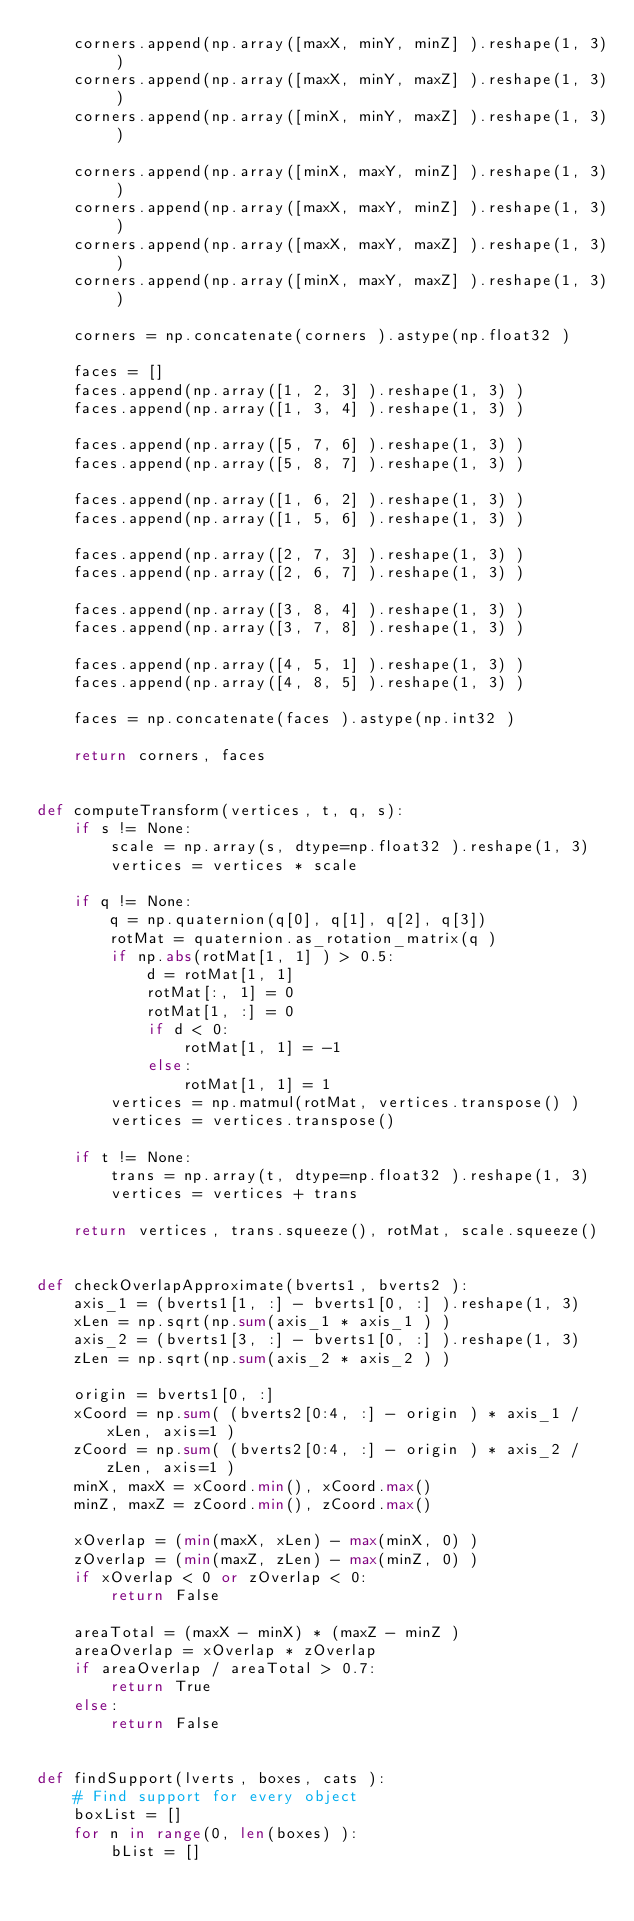Convert code to text. <code><loc_0><loc_0><loc_500><loc_500><_Python_>    corners.append(np.array([maxX, minY, minZ] ).reshape(1, 3) )
    corners.append(np.array([maxX, minY, maxZ] ).reshape(1, 3) )
    corners.append(np.array([minX, minY, maxZ] ).reshape(1, 3) )

    corners.append(np.array([minX, maxY, minZ] ).reshape(1, 3) )
    corners.append(np.array([maxX, maxY, minZ] ).reshape(1, 3) )
    corners.append(np.array([maxX, maxY, maxZ] ).reshape(1, 3) )
    corners.append(np.array([minX, maxY, maxZ] ).reshape(1, 3) )

    corners = np.concatenate(corners ).astype(np.float32 )

    faces = []
    faces.append(np.array([1, 2, 3] ).reshape(1, 3) )
    faces.append(np.array([1, 3, 4] ).reshape(1, 3) )

    faces.append(np.array([5, 7, 6] ).reshape(1, 3) )
    faces.append(np.array([5, 8, 7] ).reshape(1, 3) )

    faces.append(np.array([1, 6, 2] ).reshape(1, 3) )
    faces.append(np.array([1, 5, 6] ).reshape(1, 3) )

    faces.append(np.array([2, 7, 3] ).reshape(1, 3) )
    faces.append(np.array([2, 6, 7] ).reshape(1, 3) )

    faces.append(np.array([3, 8, 4] ).reshape(1, 3) )
    faces.append(np.array([3, 7, 8] ).reshape(1, 3) )

    faces.append(np.array([4, 5, 1] ).reshape(1, 3) )
    faces.append(np.array([4, 8, 5] ).reshape(1, 3) )

    faces = np.concatenate(faces ).astype(np.int32 )

    return corners, faces


def computeTransform(vertices, t, q, s):
    if s != None:
        scale = np.array(s, dtype=np.float32 ).reshape(1, 3)
        vertices = vertices * scale

    if q != None:
        q = np.quaternion(q[0], q[1], q[2], q[3])
        rotMat = quaternion.as_rotation_matrix(q )
        if np.abs(rotMat[1, 1] ) > 0.5:
            d = rotMat[1, 1]
            rotMat[:, 1] = 0
            rotMat[1, :] = 0
            if d < 0:
                rotMat[1, 1] = -1
            else:
                rotMat[1, 1] = 1
        vertices = np.matmul(rotMat, vertices.transpose() )
        vertices = vertices.transpose()

    if t != None:
        trans = np.array(t, dtype=np.float32 ).reshape(1, 3)
        vertices = vertices + trans

    return vertices, trans.squeeze(), rotMat, scale.squeeze()


def checkOverlapApproximate(bverts1, bverts2 ):
    axis_1 = (bverts1[1, :] - bverts1[0, :] ).reshape(1, 3)
    xLen = np.sqrt(np.sum(axis_1 * axis_1 ) )
    axis_2 = (bverts1[3, :] - bverts1[0, :] ).reshape(1, 3)
    zLen = np.sqrt(np.sum(axis_2 * axis_2 ) )

    origin = bverts1[0, :]
    xCoord = np.sum( (bverts2[0:4, :] - origin ) * axis_1 / xLen, axis=1 )
    zCoord = np.sum( (bverts2[0:4, :] - origin ) * axis_2 / zLen, axis=1 )
    minX, maxX = xCoord.min(), xCoord.max()
    minZ, maxZ = zCoord.min(), zCoord.max()

    xOverlap = (min(maxX, xLen) - max(minX, 0) )
    zOverlap = (min(maxZ, zLen) - max(minZ, 0) )
    if xOverlap < 0 or zOverlap < 0:
        return False

    areaTotal = (maxX - minX) * (maxZ - minZ )
    areaOverlap = xOverlap * zOverlap
    if areaOverlap / areaTotal > 0.7:
        return True
    else:
        return False


def findSupport(lverts, boxes, cats ):
    # Find support for every object
    boxList = []
    for n in range(0, len(boxes) ):
        bList = []</code> 